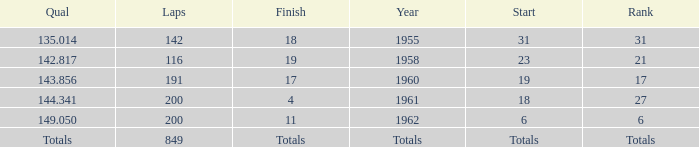What is the year with 116 laps? 1958.0. 